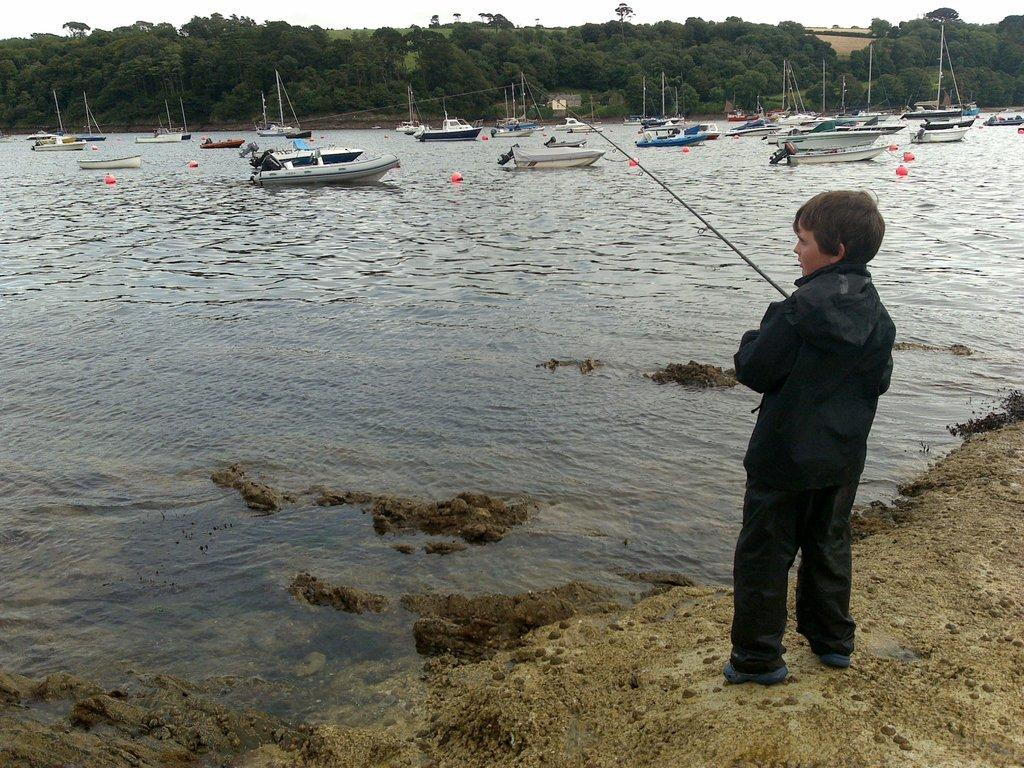What is the main subject on the right side of the image? There is a boy on the right side of the image. What is the boy doing in the image? The boy is on the ground and holding a fish catcher. What can be seen in the background of the image? There is water, boats, balloons, trees, and the sky visible in the background of the image. What type of toothbrush is the boy using to catch fish in the image? There is no toothbrush present in the image; the boy is using a fish catcher to catch fish. What educational institution can be seen in the background of the image? There is no educational institution present in the image; the background features water, boats, balloons, trees, and the sky. 